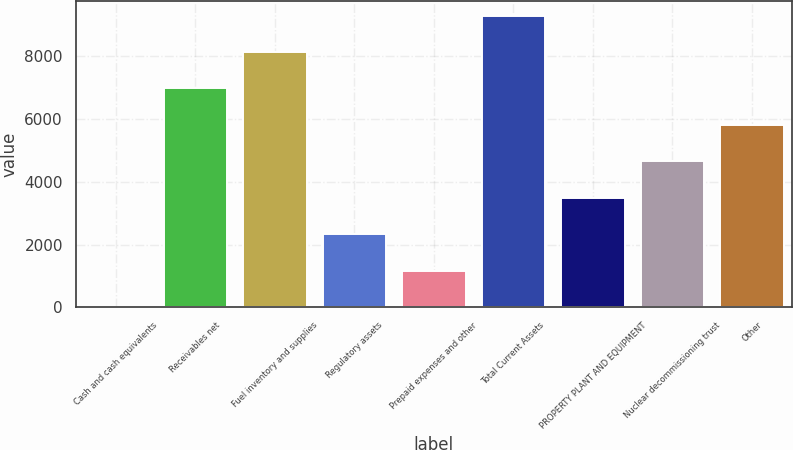Convert chart to OTSL. <chart><loc_0><loc_0><loc_500><loc_500><bar_chart><fcel>Cash and cash equivalents<fcel>Receivables net<fcel>Fuel inventory and supplies<fcel>Regulatory assets<fcel>Prepaid expenses and other<fcel>Total Current Assets<fcel>PROPERTY PLANT AND EQUIPMENT<fcel>Nuclear decommissioning trust<fcel>Other<nl><fcel>3.4<fcel>6976<fcel>8138.1<fcel>2327.6<fcel>1165.5<fcel>9300.2<fcel>3489.7<fcel>4651.8<fcel>5813.9<nl></chart> 